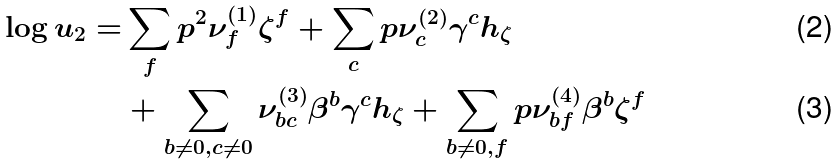Convert formula to latex. <formula><loc_0><loc_0><loc_500><loc_500>\log u _ { 2 } = & \sum _ { f } p ^ { 2 } \nu ^ { ( 1 ) } _ { f } \zeta ^ { f } + \sum _ { c } p \nu ^ { ( 2 ) } _ { c } \gamma ^ { c } h _ { \zeta } \\ & + \sum _ { b \neq 0 , c \neq 0 } \nu ^ { ( 3 ) } _ { b c } \beta ^ { b } \gamma ^ { c } h _ { \zeta } + \sum _ { b \neq 0 , f } p \nu ^ { ( 4 ) } _ { b f } \beta ^ { b } \zeta ^ { f }</formula> 